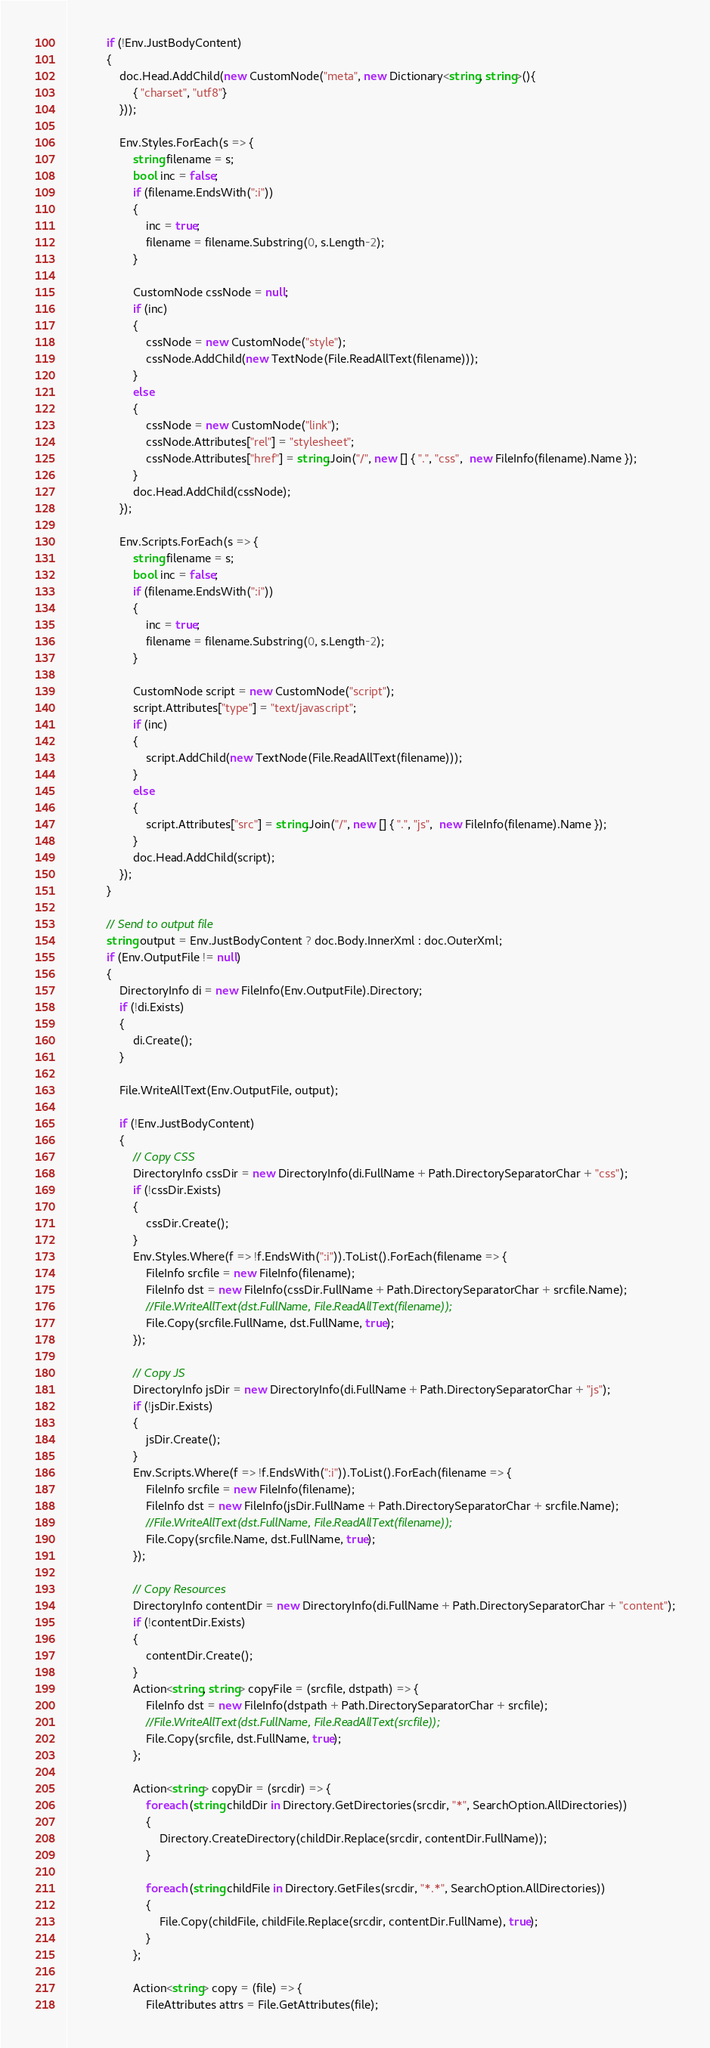Convert code to text. <code><loc_0><loc_0><loc_500><loc_500><_C#_>            if (!Env.JustBodyContent)
            {
                doc.Head.AddChild(new CustomNode("meta", new Dictionary<string, string>(){
                    { "charset", "utf8"}
                }));

                Env.Styles.ForEach(s => {
                    string filename = s;
                    bool inc = false;
                    if (filename.EndsWith(":i"))
                    {
                        inc = true;
                        filename = filename.Substring(0, s.Length-2);
                    }
                    
                    CustomNode cssNode = null;
                    if (inc)
                    {
                        cssNode = new CustomNode("style");
                        cssNode.AddChild(new TextNode(File.ReadAllText(filename)));
                    }
                    else
                    {
                        cssNode = new CustomNode("link");
                        cssNode.Attributes["rel"] = "stylesheet";
                        cssNode.Attributes["href"] = string.Join("/", new [] { ".", "css",  new FileInfo(filename).Name });
                    }
                    doc.Head.AddChild(cssNode);
                });

                Env.Scripts.ForEach(s => {
                    string filename = s;
                    bool inc = false;
                    if (filename.EndsWith(":i"))
                    {
                        inc = true;
                        filename = filename.Substring(0, s.Length-2);
                    }
                    
                    CustomNode script = new CustomNode("script");
                    script.Attributes["type"] = "text/javascript";
                    if (inc)
                    {
                        script.AddChild(new TextNode(File.ReadAllText(filename)));
                    }
                    else
                    {
                        script.Attributes["src"] = string.Join("/", new [] { ".", "js",  new FileInfo(filename).Name });
                    }
                    doc.Head.AddChild(script);
                });
            }

            // Send to output file
            string output = Env.JustBodyContent ? doc.Body.InnerXml : doc.OuterXml;
            if (Env.OutputFile != null)
            {
                DirectoryInfo di = new FileInfo(Env.OutputFile).Directory;
                if (!di.Exists)
                {
                    di.Create();
                }

                File.WriteAllText(Env.OutputFile, output);

                if (!Env.JustBodyContent)
                {
                    // Copy CSS
                    DirectoryInfo cssDir = new DirectoryInfo(di.FullName + Path.DirectorySeparatorChar + "css");
                    if (!cssDir.Exists)
                    {
                        cssDir.Create();
                    }
                    Env.Styles.Where(f => !f.EndsWith(":i")).ToList().ForEach(filename => {
                        FileInfo srcfile = new FileInfo(filename);
                        FileInfo dst = new FileInfo(cssDir.FullName + Path.DirectorySeparatorChar + srcfile.Name);
                        //File.WriteAllText(dst.FullName, File.ReadAllText(filename));
                        File.Copy(srcfile.FullName, dst.FullName, true);
                    });

                    // Copy JS
                    DirectoryInfo jsDir = new DirectoryInfo(di.FullName + Path.DirectorySeparatorChar + "js");
                    if (!jsDir.Exists)
                    {
                        jsDir.Create();
                    }
                    Env.Scripts.Where(f => !f.EndsWith(":i")).ToList().ForEach(filename => {
                        FileInfo srcfile = new FileInfo(filename);
                        FileInfo dst = new FileInfo(jsDir.FullName + Path.DirectorySeparatorChar + srcfile.Name);
                        //File.WriteAllText(dst.FullName, File.ReadAllText(filename));
                        File.Copy(srcfile.Name, dst.FullName, true);
                    });

                    // Copy Resources
                    DirectoryInfo contentDir = new DirectoryInfo(di.FullName + Path.DirectorySeparatorChar + "content");
                    if (!contentDir.Exists)
                    {
                        contentDir.Create();
                    }
                    Action<string, string> copyFile = (srcfile, dstpath) => {
                        FileInfo dst = new FileInfo(dstpath + Path.DirectorySeparatorChar + srcfile);
                        //File.WriteAllText(dst.FullName, File.ReadAllText(srcfile));
                        File.Copy(srcfile, dst.FullName, true);
                    };

                    Action<string> copyDir = (srcdir) => {
                        foreach (string childDir in Directory.GetDirectories(srcdir, "*", SearchOption.AllDirectories))
                        {
                            Directory.CreateDirectory(childDir.Replace(srcdir, contentDir.FullName));
                        }

                        foreach (string childFile in Directory.GetFiles(srcdir, "*.*", SearchOption.AllDirectories))
                        {
                            File.Copy(childFile, childFile.Replace(srcdir, contentDir.FullName), true);
                        }
                    };

                    Action<string> copy = (file) => {
                        FileAttributes attrs = File.GetAttributes(file);</code> 